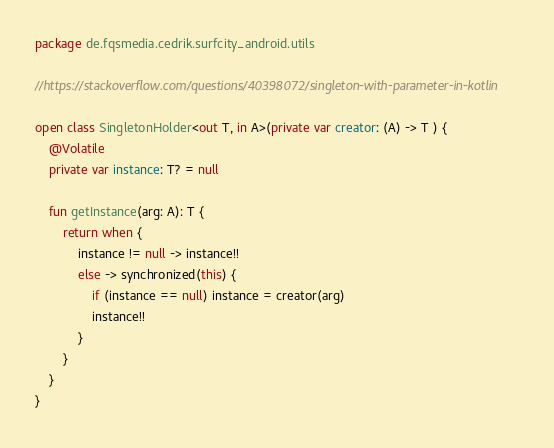Convert code to text. <code><loc_0><loc_0><loc_500><loc_500><_Kotlin_>package de.fqsmedia.cedrik.surfcity_android.utils

//https://stackoverflow.com/questions/40398072/singleton-with-parameter-in-kotlin

open class SingletonHolder<out T, in A>(private var creator: (A) -> T ) {
    @Volatile
    private var instance: T? = null

    fun getInstance(arg: A): T {
        return when {
            instance != null -> instance!!
            else -> synchronized(this) {
                if (instance == null) instance = creator(arg)
                instance!!
            }
        }
    }
}</code> 